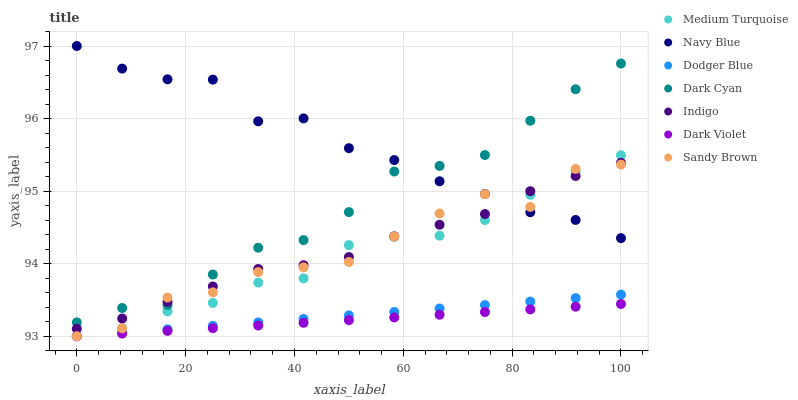Does Dark Violet have the minimum area under the curve?
Answer yes or no. Yes. Does Navy Blue have the maximum area under the curve?
Answer yes or no. Yes. Does Navy Blue have the minimum area under the curve?
Answer yes or no. No. Does Dark Violet have the maximum area under the curve?
Answer yes or no. No. Is Dark Violet the smoothest?
Answer yes or no. Yes. Is Sandy Brown the roughest?
Answer yes or no. Yes. Is Navy Blue the smoothest?
Answer yes or no. No. Is Navy Blue the roughest?
Answer yes or no. No. Does Dark Violet have the lowest value?
Answer yes or no. Yes. Does Navy Blue have the lowest value?
Answer yes or no. No. Does Navy Blue have the highest value?
Answer yes or no. Yes. Does Dark Violet have the highest value?
Answer yes or no. No. Is Dark Violet less than Medium Turquoise?
Answer yes or no. Yes. Is Dark Cyan greater than Dodger Blue?
Answer yes or no. Yes. Does Navy Blue intersect Dark Cyan?
Answer yes or no. Yes. Is Navy Blue less than Dark Cyan?
Answer yes or no. No. Is Navy Blue greater than Dark Cyan?
Answer yes or no. No. Does Dark Violet intersect Medium Turquoise?
Answer yes or no. No. 